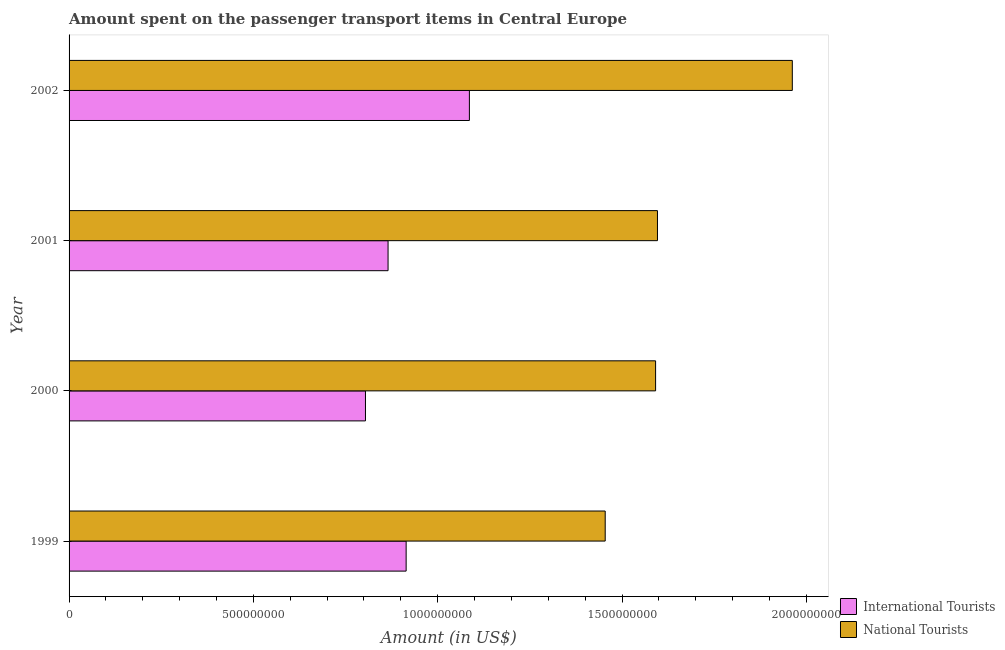What is the label of the 2nd group of bars from the top?
Your answer should be compact. 2001. In how many cases, is the number of bars for a given year not equal to the number of legend labels?
Ensure brevity in your answer.  0. What is the amount spent on transport items of national tourists in 1999?
Your response must be concise. 1.45e+09. Across all years, what is the maximum amount spent on transport items of international tourists?
Provide a short and direct response. 1.09e+09. Across all years, what is the minimum amount spent on transport items of national tourists?
Offer a very short reply. 1.45e+09. In which year was the amount spent on transport items of national tourists maximum?
Provide a short and direct response. 2002. In which year was the amount spent on transport items of national tourists minimum?
Offer a very short reply. 1999. What is the total amount spent on transport items of international tourists in the graph?
Offer a very short reply. 3.67e+09. What is the difference between the amount spent on transport items of national tourists in 1999 and that in 2002?
Give a very brief answer. -5.08e+08. What is the difference between the amount spent on transport items of national tourists in 1999 and the amount spent on transport items of international tourists in 2000?
Your answer should be compact. 6.50e+08. What is the average amount spent on transport items of national tourists per year?
Your answer should be very brief. 1.65e+09. In the year 2002, what is the difference between the amount spent on transport items of international tourists and amount spent on transport items of national tourists?
Provide a short and direct response. -8.76e+08. In how many years, is the amount spent on transport items of international tourists greater than 1000000000 US$?
Your response must be concise. 1. What is the ratio of the amount spent on transport items of international tourists in 1999 to that in 2000?
Offer a very short reply. 1.14. Is the amount spent on transport items of national tourists in 1999 less than that in 2001?
Offer a very short reply. Yes. Is the difference between the amount spent on transport items of international tourists in 2001 and 2002 greater than the difference between the amount spent on transport items of national tourists in 2001 and 2002?
Your answer should be very brief. Yes. What is the difference between the highest and the second highest amount spent on transport items of national tourists?
Offer a terse response. 3.66e+08. What is the difference between the highest and the lowest amount spent on transport items of international tourists?
Make the answer very short. 2.82e+08. In how many years, is the amount spent on transport items of national tourists greater than the average amount spent on transport items of national tourists taken over all years?
Your answer should be compact. 1. Is the sum of the amount spent on transport items of international tourists in 1999 and 2001 greater than the maximum amount spent on transport items of national tourists across all years?
Provide a short and direct response. No. What does the 1st bar from the top in 2002 represents?
Make the answer very short. National Tourists. What does the 1st bar from the bottom in 1999 represents?
Provide a succinct answer. International Tourists. How many years are there in the graph?
Give a very brief answer. 4. Are the values on the major ticks of X-axis written in scientific E-notation?
Your response must be concise. No. Where does the legend appear in the graph?
Your answer should be very brief. Bottom right. How many legend labels are there?
Your answer should be very brief. 2. What is the title of the graph?
Your response must be concise. Amount spent on the passenger transport items in Central Europe. Does "Boys" appear as one of the legend labels in the graph?
Offer a terse response. No. What is the label or title of the X-axis?
Offer a very short reply. Amount (in US$). What is the label or title of the Y-axis?
Your response must be concise. Year. What is the Amount (in US$) in International Tourists in 1999?
Your response must be concise. 9.14e+08. What is the Amount (in US$) in National Tourists in 1999?
Give a very brief answer. 1.45e+09. What is the Amount (in US$) in International Tourists in 2000?
Give a very brief answer. 8.04e+08. What is the Amount (in US$) of National Tourists in 2000?
Your answer should be very brief. 1.59e+09. What is the Amount (in US$) of International Tourists in 2001?
Keep it short and to the point. 8.65e+08. What is the Amount (in US$) in National Tourists in 2001?
Provide a succinct answer. 1.60e+09. What is the Amount (in US$) of International Tourists in 2002?
Your answer should be compact. 1.09e+09. What is the Amount (in US$) in National Tourists in 2002?
Give a very brief answer. 1.96e+09. Across all years, what is the maximum Amount (in US$) in International Tourists?
Give a very brief answer. 1.09e+09. Across all years, what is the maximum Amount (in US$) in National Tourists?
Your response must be concise. 1.96e+09. Across all years, what is the minimum Amount (in US$) in International Tourists?
Make the answer very short. 8.04e+08. Across all years, what is the minimum Amount (in US$) in National Tourists?
Keep it short and to the point. 1.45e+09. What is the total Amount (in US$) of International Tourists in the graph?
Offer a terse response. 3.67e+09. What is the total Amount (in US$) of National Tourists in the graph?
Your response must be concise. 6.60e+09. What is the difference between the Amount (in US$) of International Tourists in 1999 and that in 2000?
Your response must be concise. 1.10e+08. What is the difference between the Amount (in US$) of National Tourists in 1999 and that in 2000?
Give a very brief answer. -1.37e+08. What is the difference between the Amount (in US$) of International Tourists in 1999 and that in 2001?
Keep it short and to the point. 4.90e+07. What is the difference between the Amount (in US$) in National Tourists in 1999 and that in 2001?
Your response must be concise. -1.42e+08. What is the difference between the Amount (in US$) of International Tourists in 1999 and that in 2002?
Ensure brevity in your answer.  -1.72e+08. What is the difference between the Amount (in US$) of National Tourists in 1999 and that in 2002?
Provide a succinct answer. -5.08e+08. What is the difference between the Amount (in US$) in International Tourists in 2000 and that in 2001?
Make the answer very short. -6.13e+07. What is the difference between the Amount (in US$) of National Tourists in 2000 and that in 2001?
Your answer should be very brief. -5.06e+06. What is the difference between the Amount (in US$) of International Tourists in 2000 and that in 2002?
Your response must be concise. -2.82e+08. What is the difference between the Amount (in US$) in National Tourists in 2000 and that in 2002?
Make the answer very short. -3.71e+08. What is the difference between the Amount (in US$) in International Tourists in 2001 and that in 2002?
Your answer should be compact. -2.21e+08. What is the difference between the Amount (in US$) in National Tourists in 2001 and that in 2002?
Keep it short and to the point. -3.66e+08. What is the difference between the Amount (in US$) in International Tourists in 1999 and the Amount (in US$) in National Tourists in 2000?
Make the answer very short. -6.77e+08. What is the difference between the Amount (in US$) of International Tourists in 1999 and the Amount (in US$) of National Tourists in 2001?
Offer a terse response. -6.82e+08. What is the difference between the Amount (in US$) of International Tourists in 1999 and the Amount (in US$) of National Tourists in 2002?
Ensure brevity in your answer.  -1.05e+09. What is the difference between the Amount (in US$) in International Tourists in 2000 and the Amount (in US$) in National Tourists in 2001?
Your answer should be compact. -7.92e+08. What is the difference between the Amount (in US$) in International Tourists in 2000 and the Amount (in US$) in National Tourists in 2002?
Your answer should be very brief. -1.16e+09. What is the difference between the Amount (in US$) in International Tourists in 2001 and the Amount (in US$) in National Tourists in 2002?
Offer a terse response. -1.10e+09. What is the average Amount (in US$) in International Tourists per year?
Provide a succinct answer. 9.17e+08. What is the average Amount (in US$) in National Tourists per year?
Provide a succinct answer. 1.65e+09. In the year 1999, what is the difference between the Amount (in US$) of International Tourists and Amount (in US$) of National Tourists?
Offer a terse response. -5.40e+08. In the year 2000, what is the difference between the Amount (in US$) of International Tourists and Amount (in US$) of National Tourists?
Ensure brevity in your answer.  -7.87e+08. In the year 2001, what is the difference between the Amount (in US$) in International Tourists and Amount (in US$) in National Tourists?
Your answer should be compact. -7.31e+08. In the year 2002, what is the difference between the Amount (in US$) of International Tourists and Amount (in US$) of National Tourists?
Keep it short and to the point. -8.76e+08. What is the ratio of the Amount (in US$) of International Tourists in 1999 to that in 2000?
Make the answer very short. 1.14. What is the ratio of the Amount (in US$) of National Tourists in 1999 to that in 2000?
Make the answer very short. 0.91. What is the ratio of the Amount (in US$) of International Tourists in 1999 to that in 2001?
Provide a succinct answer. 1.06. What is the ratio of the Amount (in US$) in National Tourists in 1999 to that in 2001?
Offer a terse response. 0.91. What is the ratio of the Amount (in US$) of International Tourists in 1999 to that in 2002?
Keep it short and to the point. 0.84. What is the ratio of the Amount (in US$) in National Tourists in 1999 to that in 2002?
Keep it short and to the point. 0.74. What is the ratio of the Amount (in US$) in International Tourists in 2000 to that in 2001?
Offer a terse response. 0.93. What is the ratio of the Amount (in US$) of International Tourists in 2000 to that in 2002?
Your answer should be very brief. 0.74. What is the ratio of the Amount (in US$) of National Tourists in 2000 to that in 2002?
Your response must be concise. 0.81. What is the ratio of the Amount (in US$) in International Tourists in 2001 to that in 2002?
Offer a terse response. 0.8. What is the ratio of the Amount (in US$) in National Tourists in 2001 to that in 2002?
Make the answer very short. 0.81. What is the difference between the highest and the second highest Amount (in US$) in International Tourists?
Offer a terse response. 1.72e+08. What is the difference between the highest and the second highest Amount (in US$) of National Tourists?
Your answer should be very brief. 3.66e+08. What is the difference between the highest and the lowest Amount (in US$) of International Tourists?
Make the answer very short. 2.82e+08. What is the difference between the highest and the lowest Amount (in US$) in National Tourists?
Offer a terse response. 5.08e+08. 